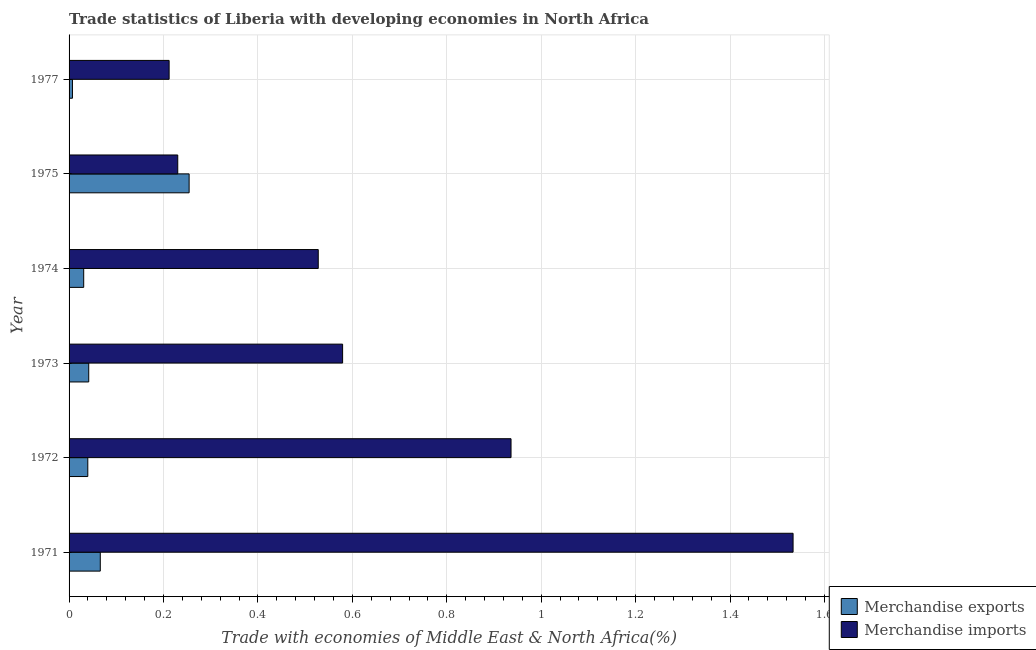How many different coloured bars are there?
Ensure brevity in your answer.  2. What is the label of the 4th group of bars from the top?
Offer a terse response. 1973. In how many cases, is the number of bars for a given year not equal to the number of legend labels?
Give a very brief answer. 0. What is the merchandise imports in 1972?
Offer a terse response. 0.94. Across all years, what is the maximum merchandise exports?
Provide a short and direct response. 0.25. Across all years, what is the minimum merchandise exports?
Offer a terse response. 0.01. In which year was the merchandise imports maximum?
Provide a succinct answer. 1971. In which year was the merchandise exports minimum?
Keep it short and to the point. 1977. What is the total merchandise exports in the graph?
Your response must be concise. 0.44. What is the difference between the merchandise exports in 1974 and that in 1975?
Provide a succinct answer. -0.22. What is the difference between the merchandise exports in 1975 and the merchandise imports in 1972?
Ensure brevity in your answer.  -0.68. What is the average merchandise imports per year?
Offer a terse response. 0.67. In the year 1974, what is the difference between the merchandise exports and merchandise imports?
Offer a terse response. -0.5. In how many years, is the merchandise exports greater than 0.6400000000000001 %?
Your answer should be compact. 0. Is the difference between the merchandise imports in 1973 and 1977 greater than the difference between the merchandise exports in 1973 and 1977?
Provide a short and direct response. Yes. What is the difference between the highest and the second highest merchandise exports?
Ensure brevity in your answer.  0.19. What is the difference between the highest and the lowest merchandise exports?
Offer a terse response. 0.25. In how many years, is the merchandise imports greater than the average merchandise imports taken over all years?
Your answer should be compact. 2. What does the 2nd bar from the top in 1973 represents?
Offer a very short reply. Merchandise exports. Does the graph contain any zero values?
Offer a terse response. No. Does the graph contain grids?
Your answer should be compact. Yes. Where does the legend appear in the graph?
Offer a very short reply. Bottom right. What is the title of the graph?
Keep it short and to the point. Trade statistics of Liberia with developing economies in North Africa. Does "Grants" appear as one of the legend labels in the graph?
Provide a succinct answer. No. What is the label or title of the X-axis?
Your answer should be compact. Trade with economies of Middle East & North Africa(%). What is the Trade with economies of Middle East & North Africa(%) in Merchandise exports in 1971?
Your response must be concise. 0.07. What is the Trade with economies of Middle East & North Africa(%) in Merchandise imports in 1971?
Provide a succinct answer. 1.53. What is the Trade with economies of Middle East & North Africa(%) in Merchandise exports in 1972?
Your answer should be very brief. 0.04. What is the Trade with economies of Middle East & North Africa(%) of Merchandise imports in 1972?
Provide a succinct answer. 0.94. What is the Trade with economies of Middle East & North Africa(%) of Merchandise exports in 1973?
Offer a terse response. 0.04. What is the Trade with economies of Middle East & North Africa(%) of Merchandise imports in 1973?
Your answer should be very brief. 0.58. What is the Trade with economies of Middle East & North Africa(%) of Merchandise exports in 1974?
Make the answer very short. 0.03. What is the Trade with economies of Middle East & North Africa(%) in Merchandise imports in 1974?
Your answer should be compact. 0.53. What is the Trade with economies of Middle East & North Africa(%) in Merchandise exports in 1975?
Make the answer very short. 0.25. What is the Trade with economies of Middle East & North Africa(%) in Merchandise imports in 1975?
Offer a very short reply. 0.23. What is the Trade with economies of Middle East & North Africa(%) of Merchandise exports in 1977?
Provide a short and direct response. 0.01. What is the Trade with economies of Middle East & North Africa(%) of Merchandise imports in 1977?
Your answer should be compact. 0.21. Across all years, what is the maximum Trade with economies of Middle East & North Africa(%) in Merchandise exports?
Provide a succinct answer. 0.25. Across all years, what is the maximum Trade with economies of Middle East & North Africa(%) in Merchandise imports?
Make the answer very short. 1.53. Across all years, what is the minimum Trade with economies of Middle East & North Africa(%) in Merchandise exports?
Your answer should be compact. 0.01. Across all years, what is the minimum Trade with economies of Middle East & North Africa(%) of Merchandise imports?
Offer a very short reply. 0.21. What is the total Trade with economies of Middle East & North Africa(%) in Merchandise exports in the graph?
Give a very brief answer. 0.44. What is the total Trade with economies of Middle East & North Africa(%) of Merchandise imports in the graph?
Provide a short and direct response. 4.02. What is the difference between the Trade with economies of Middle East & North Africa(%) of Merchandise exports in 1971 and that in 1972?
Ensure brevity in your answer.  0.03. What is the difference between the Trade with economies of Middle East & North Africa(%) in Merchandise imports in 1971 and that in 1972?
Give a very brief answer. 0.6. What is the difference between the Trade with economies of Middle East & North Africa(%) of Merchandise exports in 1971 and that in 1973?
Provide a succinct answer. 0.02. What is the difference between the Trade with economies of Middle East & North Africa(%) in Merchandise imports in 1971 and that in 1973?
Ensure brevity in your answer.  0.95. What is the difference between the Trade with economies of Middle East & North Africa(%) in Merchandise exports in 1971 and that in 1974?
Your answer should be compact. 0.04. What is the difference between the Trade with economies of Middle East & North Africa(%) in Merchandise exports in 1971 and that in 1975?
Ensure brevity in your answer.  -0.19. What is the difference between the Trade with economies of Middle East & North Africa(%) in Merchandise imports in 1971 and that in 1975?
Your response must be concise. 1.3. What is the difference between the Trade with economies of Middle East & North Africa(%) in Merchandise exports in 1971 and that in 1977?
Provide a succinct answer. 0.06. What is the difference between the Trade with economies of Middle East & North Africa(%) of Merchandise imports in 1971 and that in 1977?
Offer a terse response. 1.32. What is the difference between the Trade with economies of Middle East & North Africa(%) in Merchandise exports in 1972 and that in 1973?
Your response must be concise. -0. What is the difference between the Trade with economies of Middle East & North Africa(%) of Merchandise imports in 1972 and that in 1973?
Your response must be concise. 0.36. What is the difference between the Trade with economies of Middle East & North Africa(%) of Merchandise exports in 1972 and that in 1974?
Give a very brief answer. 0.01. What is the difference between the Trade with economies of Middle East & North Africa(%) of Merchandise imports in 1972 and that in 1974?
Offer a very short reply. 0.41. What is the difference between the Trade with economies of Middle East & North Africa(%) in Merchandise exports in 1972 and that in 1975?
Offer a very short reply. -0.21. What is the difference between the Trade with economies of Middle East & North Africa(%) in Merchandise imports in 1972 and that in 1975?
Your response must be concise. 0.71. What is the difference between the Trade with economies of Middle East & North Africa(%) in Merchandise exports in 1972 and that in 1977?
Provide a short and direct response. 0.03. What is the difference between the Trade with economies of Middle East & North Africa(%) of Merchandise imports in 1972 and that in 1977?
Ensure brevity in your answer.  0.72. What is the difference between the Trade with economies of Middle East & North Africa(%) in Merchandise exports in 1973 and that in 1974?
Keep it short and to the point. 0.01. What is the difference between the Trade with economies of Middle East & North Africa(%) of Merchandise imports in 1973 and that in 1974?
Provide a short and direct response. 0.05. What is the difference between the Trade with economies of Middle East & North Africa(%) of Merchandise exports in 1973 and that in 1975?
Your response must be concise. -0.21. What is the difference between the Trade with economies of Middle East & North Africa(%) in Merchandise imports in 1973 and that in 1975?
Make the answer very short. 0.35. What is the difference between the Trade with economies of Middle East & North Africa(%) in Merchandise exports in 1973 and that in 1977?
Offer a terse response. 0.03. What is the difference between the Trade with economies of Middle East & North Africa(%) of Merchandise imports in 1973 and that in 1977?
Provide a succinct answer. 0.37. What is the difference between the Trade with economies of Middle East & North Africa(%) of Merchandise exports in 1974 and that in 1975?
Give a very brief answer. -0.22. What is the difference between the Trade with economies of Middle East & North Africa(%) of Merchandise imports in 1974 and that in 1975?
Keep it short and to the point. 0.3. What is the difference between the Trade with economies of Middle East & North Africa(%) in Merchandise exports in 1974 and that in 1977?
Offer a very short reply. 0.02. What is the difference between the Trade with economies of Middle East & North Africa(%) in Merchandise imports in 1974 and that in 1977?
Make the answer very short. 0.32. What is the difference between the Trade with economies of Middle East & North Africa(%) in Merchandise exports in 1975 and that in 1977?
Provide a succinct answer. 0.25. What is the difference between the Trade with economies of Middle East & North Africa(%) of Merchandise imports in 1975 and that in 1977?
Keep it short and to the point. 0.02. What is the difference between the Trade with economies of Middle East & North Africa(%) of Merchandise exports in 1971 and the Trade with economies of Middle East & North Africa(%) of Merchandise imports in 1972?
Provide a short and direct response. -0.87. What is the difference between the Trade with economies of Middle East & North Africa(%) in Merchandise exports in 1971 and the Trade with economies of Middle East & North Africa(%) in Merchandise imports in 1973?
Your response must be concise. -0.51. What is the difference between the Trade with economies of Middle East & North Africa(%) in Merchandise exports in 1971 and the Trade with economies of Middle East & North Africa(%) in Merchandise imports in 1974?
Ensure brevity in your answer.  -0.46. What is the difference between the Trade with economies of Middle East & North Africa(%) of Merchandise exports in 1971 and the Trade with economies of Middle East & North Africa(%) of Merchandise imports in 1975?
Ensure brevity in your answer.  -0.16. What is the difference between the Trade with economies of Middle East & North Africa(%) in Merchandise exports in 1971 and the Trade with economies of Middle East & North Africa(%) in Merchandise imports in 1977?
Your response must be concise. -0.15. What is the difference between the Trade with economies of Middle East & North Africa(%) of Merchandise exports in 1972 and the Trade with economies of Middle East & North Africa(%) of Merchandise imports in 1973?
Offer a very short reply. -0.54. What is the difference between the Trade with economies of Middle East & North Africa(%) in Merchandise exports in 1972 and the Trade with economies of Middle East & North Africa(%) in Merchandise imports in 1974?
Offer a terse response. -0.49. What is the difference between the Trade with economies of Middle East & North Africa(%) in Merchandise exports in 1972 and the Trade with economies of Middle East & North Africa(%) in Merchandise imports in 1975?
Ensure brevity in your answer.  -0.19. What is the difference between the Trade with economies of Middle East & North Africa(%) in Merchandise exports in 1972 and the Trade with economies of Middle East & North Africa(%) in Merchandise imports in 1977?
Provide a succinct answer. -0.17. What is the difference between the Trade with economies of Middle East & North Africa(%) in Merchandise exports in 1973 and the Trade with economies of Middle East & North Africa(%) in Merchandise imports in 1974?
Ensure brevity in your answer.  -0.49. What is the difference between the Trade with economies of Middle East & North Africa(%) of Merchandise exports in 1973 and the Trade with economies of Middle East & North Africa(%) of Merchandise imports in 1975?
Offer a very short reply. -0.19. What is the difference between the Trade with economies of Middle East & North Africa(%) in Merchandise exports in 1973 and the Trade with economies of Middle East & North Africa(%) in Merchandise imports in 1977?
Keep it short and to the point. -0.17. What is the difference between the Trade with economies of Middle East & North Africa(%) in Merchandise exports in 1974 and the Trade with economies of Middle East & North Africa(%) in Merchandise imports in 1975?
Give a very brief answer. -0.2. What is the difference between the Trade with economies of Middle East & North Africa(%) in Merchandise exports in 1974 and the Trade with economies of Middle East & North Africa(%) in Merchandise imports in 1977?
Provide a short and direct response. -0.18. What is the difference between the Trade with economies of Middle East & North Africa(%) of Merchandise exports in 1975 and the Trade with economies of Middle East & North Africa(%) of Merchandise imports in 1977?
Your response must be concise. 0.04. What is the average Trade with economies of Middle East & North Africa(%) in Merchandise exports per year?
Ensure brevity in your answer.  0.07. What is the average Trade with economies of Middle East & North Africa(%) of Merchandise imports per year?
Provide a short and direct response. 0.67. In the year 1971, what is the difference between the Trade with economies of Middle East & North Africa(%) of Merchandise exports and Trade with economies of Middle East & North Africa(%) of Merchandise imports?
Make the answer very short. -1.47. In the year 1972, what is the difference between the Trade with economies of Middle East & North Africa(%) of Merchandise exports and Trade with economies of Middle East & North Africa(%) of Merchandise imports?
Give a very brief answer. -0.9. In the year 1973, what is the difference between the Trade with economies of Middle East & North Africa(%) in Merchandise exports and Trade with economies of Middle East & North Africa(%) in Merchandise imports?
Make the answer very short. -0.54. In the year 1974, what is the difference between the Trade with economies of Middle East & North Africa(%) of Merchandise exports and Trade with economies of Middle East & North Africa(%) of Merchandise imports?
Make the answer very short. -0.5. In the year 1975, what is the difference between the Trade with economies of Middle East & North Africa(%) of Merchandise exports and Trade with economies of Middle East & North Africa(%) of Merchandise imports?
Ensure brevity in your answer.  0.02. In the year 1977, what is the difference between the Trade with economies of Middle East & North Africa(%) of Merchandise exports and Trade with economies of Middle East & North Africa(%) of Merchandise imports?
Offer a terse response. -0.2. What is the ratio of the Trade with economies of Middle East & North Africa(%) of Merchandise exports in 1971 to that in 1972?
Ensure brevity in your answer.  1.67. What is the ratio of the Trade with economies of Middle East & North Africa(%) of Merchandise imports in 1971 to that in 1972?
Your answer should be very brief. 1.64. What is the ratio of the Trade with economies of Middle East & North Africa(%) of Merchandise exports in 1971 to that in 1973?
Make the answer very short. 1.59. What is the ratio of the Trade with economies of Middle East & North Africa(%) of Merchandise imports in 1971 to that in 1973?
Make the answer very short. 2.65. What is the ratio of the Trade with economies of Middle East & North Africa(%) in Merchandise exports in 1971 to that in 1974?
Ensure brevity in your answer.  2.13. What is the ratio of the Trade with economies of Middle East & North Africa(%) of Merchandise imports in 1971 to that in 1974?
Make the answer very short. 2.91. What is the ratio of the Trade with economies of Middle East & North Africa(%) of Merchandise exports in 1971 to that in 1975?
Your response must be concise. 0.26. What is the ratio of the Trade with economies of Middle East & North Africa(%) of Merchandise imports in 1971 to that in 1975?
Offer a very short reply. 6.66. What is the ratio of the Trade with economies of Middle East & North Africa(%) in Merchandise exports in 1971 to that in 1977?
Your response must be concise. 9.23. What is the ratio of the Trade with economies of Middle East & North Africa(%) of Merchandise imports in 1971 to that in 1977?
Offer a terse response. 7.24. What is the ratio of the Trade with economies of Middle East & North Africa(%) in Merchandise exports in 1972 to that in 1973?
Give a very brief answer. 0.95. What is the ratio of the Trade with economies of Middle East & North Africa(%) of Merchandise imports in 1972 to that in 1973?
Provide a succinct answer. 1.62. What is the ratio of the Trade with economies of Middle East & North Africa(%) in Merchandise exports in 1972 to that in 1974?
Provide a short and direct response. 1.28. What is the ratio of the Trade with economies of Middle East & North Africa(%) in Merchandise imports in 1972 to that in 1974?
Give a very brief answer. 1.77. What is the ratio of the Trade with economies of Middle East & North Africa(%) in Merchandise exports in 1972 to that in 1975?
Offer a terse response. 0.16. What is the ratio of the Trade with economies of Middle East & North Africa(%) of Merchandise imports in 1972 to that in 1975?
Provide a succinct answer. 4.07. What is the ratio of the Trade with economies of Middle East & North Africa(%) in Merchandise exports in 1972 to that in 1977?
Keep it short and to the point. 5.54. What is the ratio of the Trade with economies of Middle East & North Africa(%) of Merchandise imports in 1972 to that in 1977?
Keep it short and to the point. 4.42. What is the ratio of the Trade with economies of Middle East & North Africa(%) in Merchandise exports in 1973 to that in 1974?
Your answer should be compact. 1.34. What is the ratio of the Trade with economies of Middle East & North Africa(%) of Merchandise imports in 1973 to that in 1974?
Make the answer very short. 1.1. What is the ratio of the Trade with economies of Middle East & North Africa(%) in Merchandise exports in 1973 to that in 1975?
Your answer should be very brief. 0.16. What is the ratio of the Trade with economies of Middle East & North Africa(%) in Merchandise imports in 1973 to that in 1975?
Offer a terse response. 2.52. What is the ratio of the Trade with economies of Middle East & North Africa(%) of Merchandise exports in 1973 to that in 1977?
Provide a succinct answer. 5.82. What is the ratio of the Trade with economies of Middle East & North Africa(%) of Merchandise imports in 1973 to that in 1977?
Your response must be concise. 2.73. What is the ratio of the Trade with economies of Middle East & North Africa(%) of Merchandise exports in 1974 to that in 1975?
Your answer should be very brief. 0.12. What is the ratio of the Trade with economies of Middle East & North Africa(%) in Merchandise imports in 1974 to that in 1975?
Give a very brief answer. 2.29. What is the ratio of the Trade with economies of Middle East & North Africa(%) in Merchandise exports in 1974 to that in 1977?
Your answer should be very brief. 4.33. What is the ratio of the Trade with economies of Middle East & North Africa(%) of Merchandise imports in 1974 to that in 1977?
Provide a short and direct response. 2.49. What is the ratio of the Trade with economies of Middle East & North Africa(%) of Merchandise exports in 1975 to that in 1977?
Your answer should be very brief. 35.51. What is the ratio of the Trade with economies of Middle East & North Africa(%) of Merchandise imports in 1975 to that in 1977?
Keep it short and to the point. 1.09. What is the difference between the highest and the second highest Trade with economies of Middle East & North Africa(%) of Merchandise exports?
Offer a very short reply. 0.19. What is the difference between the highest and the second highest Trade with economies of Middle East & North Africa(%) in Merchandise imports?
Keep it short and to the point. 0.6. What is the difference between the highest and the lowest Trade with economies of Middle East & North Africa(%) of Merchandise exports?
Offer a very short reply. 0.25. What is the difference between the highest and the lowest Trade with economies of Middle East & North Africa(%) of Merchandise imports?
Your response must be concise. 1.32. 